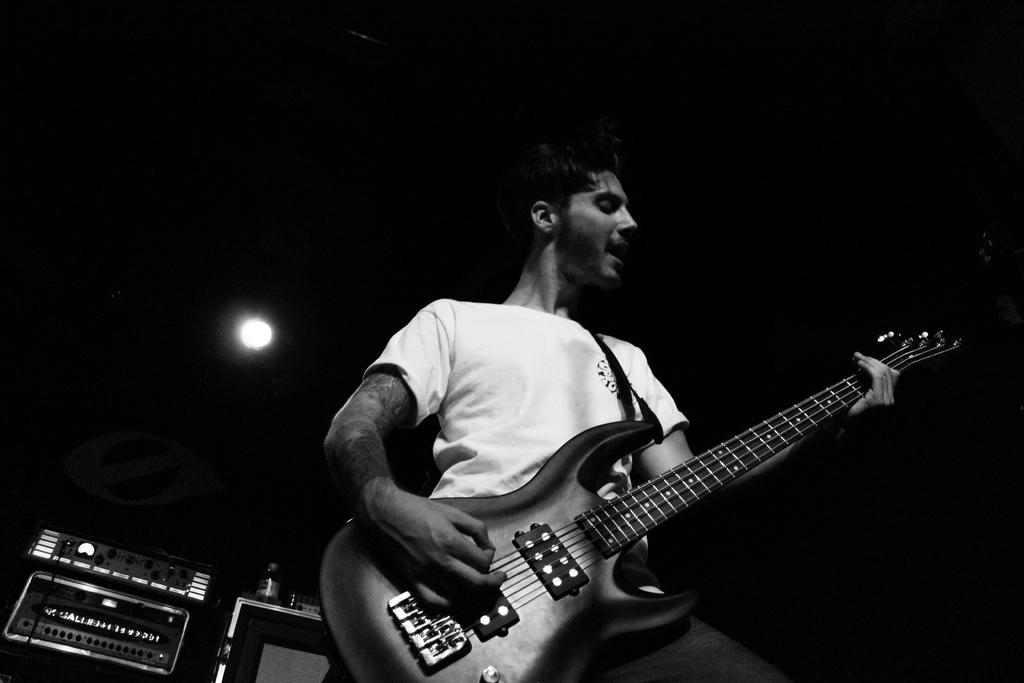In one or two sentences, can you explain what this image depicts? a person is playing guitar 